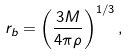<formula> <loc_0><loc_0><loc_500><loc_500>r _ { b } = \left ( \frac { 3 M } { 4 \pi \rho } \right ) ^ { 1 / 3 } ,</formula> 